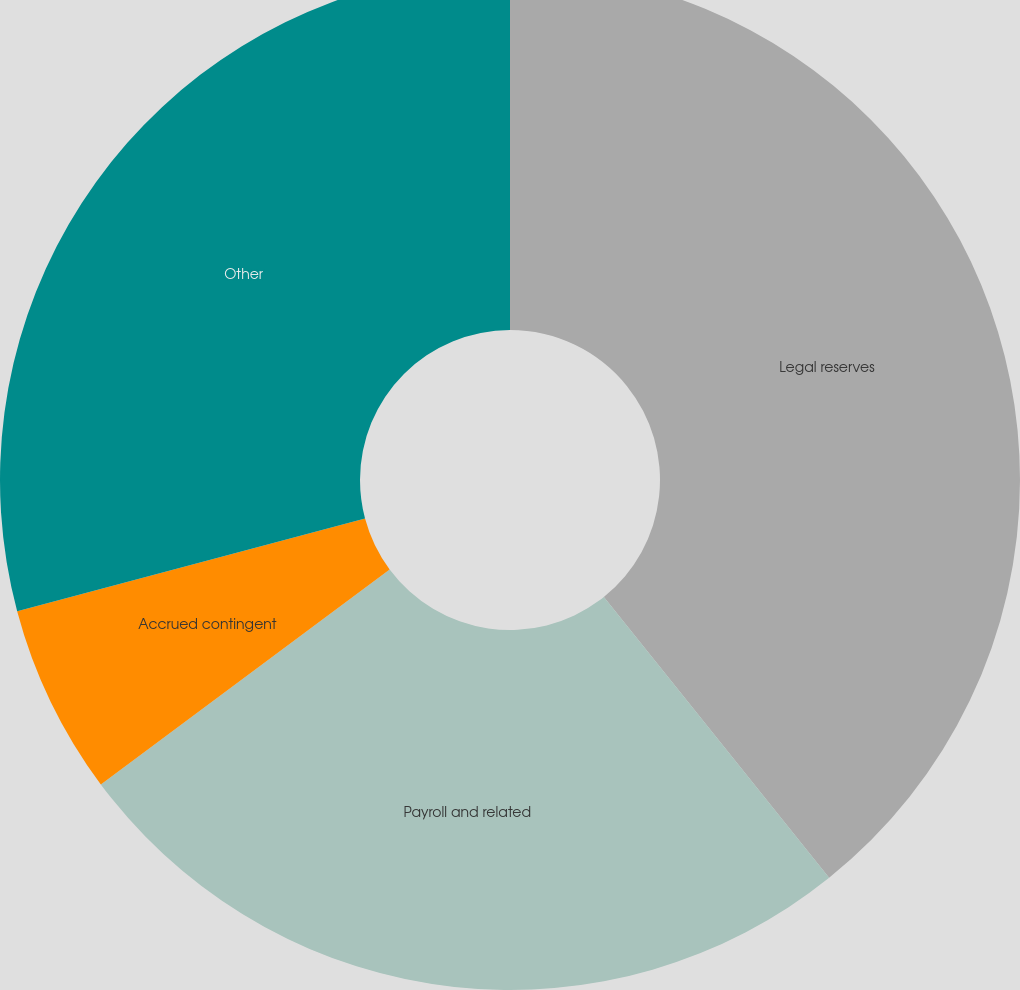Convert chart to OTSL. <chart><loc_0><loc_0><loc_500><loc_500><pie_chart><fcel>Legal reserves<fcel>Payroll and related<fcel>Accrued contingent<fcel>Other<nl><fcel>39.24%<fcel>25.58%<fcel>6.04%<fcel>29.14%<nl></chart> 